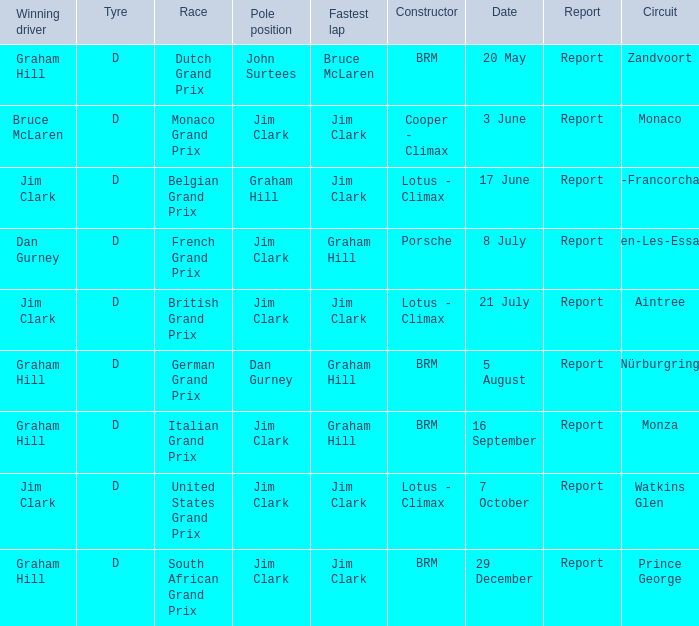What is the tyre on the race where Bruce Mclaren had the fastest lap? D. Give me the full table as a dictionary. {'header': ['Winning driver', 'Tyre', 'Race', 'Pole position', 'Fastest lap', 'Constructor', 'Date', 'Report', 'Circuit'], 'rows': [['Graham Hill', 'D', 'Dutch Grand Prix', 'John Surtees', 'Bruce McLaren', 'BRM', '20 May', 'Report', 'Zandvoort'], ['Bruce McLaren', 'D', 'Monaco Grand Prix', 'Jim Clark', 'Jim Clark', 'Cooper - Climax', '3 June', 'Report', 'Monaco'], ['Jim Clark', 'D', 'Belgian Grand Prix', 'Graham Hill', 'Jim Clark', 'Lotus - Climax', '17 June', 'Report', 'Spa-Francorchamps'], ['Dan Gurney', 'D', 'French Grand Prix', 'Jim Clark', 'Graham Hill', 'Porsche', '8 July', 'Report', 'Rouen-Les-Essarts'], ['Jim Clark', 'D', 'British Grand Prix', 'Jim Clark', 'Jim Clark', 'Lotus - Climax', '21 July', 'Report', 'Aintree'], ['Graham Hill', 'D', 'German Grand Prix', 'Dan Gurney', 'Graham Hill', 'BRM', '5 August', 'Report', 'Nürburgring'], ['Graham Hill', 'D', 'Italian Grand Prix', 'Jim Clark', 'Graham Hill', 'BRM', '16 September', 'Report', 'Monza'], ['Jim Clark', 'D', 'United States Grand Prix', 'Jim Clark', 'Jim Clark', 'Lotus - Climax', '7 October', 'Report', 'Watkins Glen'], ['Graham Hill', 'D', 'South African Grand Prix', 'Jim Clark', 'Jim Clark', 'BRM', '29 December', 'Report', 'Prince George']]} 